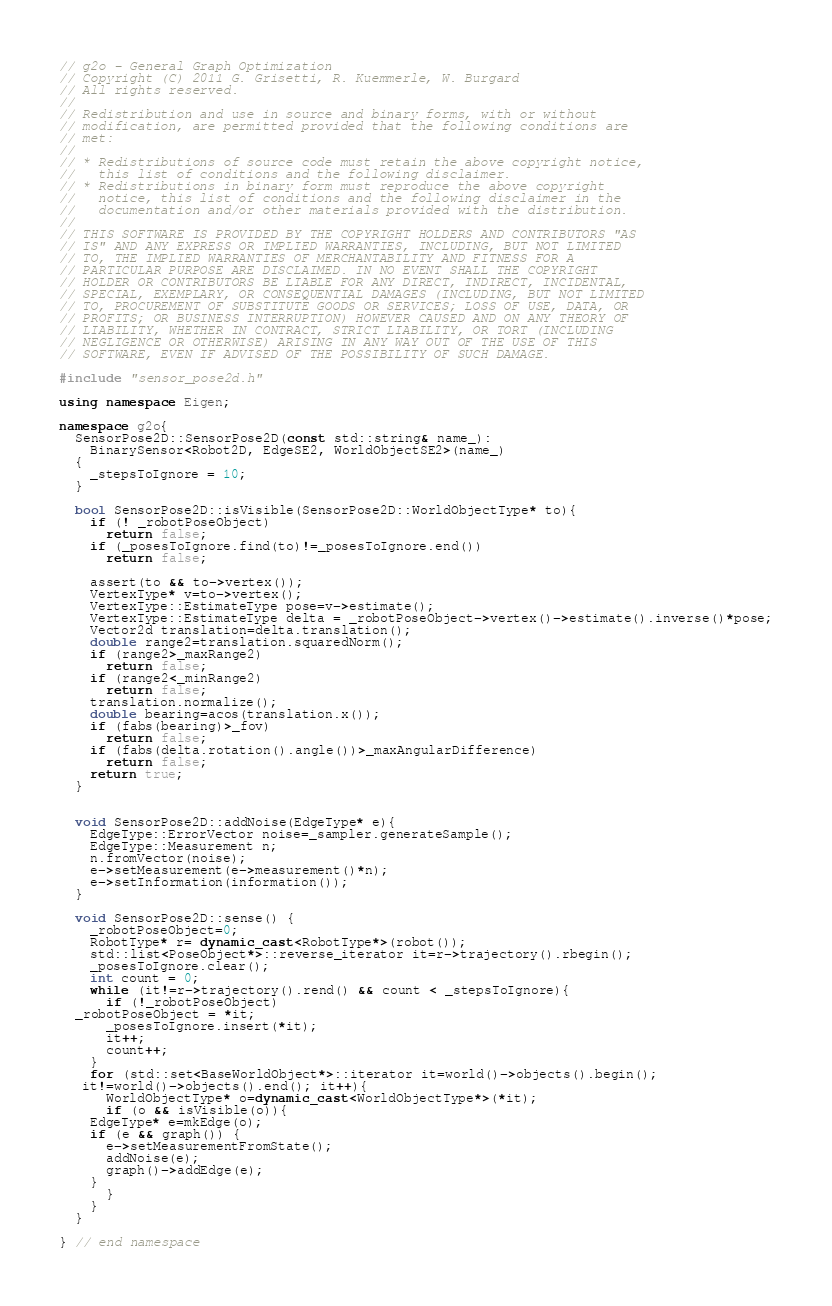Convert code to text. <code><loc_0><loc_0><loc_500><loc_500><_C++_>// g2o - General Graph Optimization
// Copyright (C) 2011 G. Grisetti, R. Kuemmerle, W. Burgard
// All rights reserved.
//
// Redistribution and use in source and binary forms, with or without
// modification, are permitted provided that the following conditions are
// met:
//
// * Redistributions of source code must retain the above copyright notice,
//   this list of conditions and the following disclaimer.
// * Redistributions in binary form must reproduce the above copyright
//   notice, this list of conditions and the following disclaimer in the
//   documentation and/or other materials provided with the distribution.
//
// THIS SOFTWARE IS PROVIDED BY THE COPYRIGHT HOLDERS AND CONTRIBUTORS "AS
// IS" AND ANY EXPRESS OR IMPLIED WARRANTIES, INCLUDING, BUT NOT LIMITED
// TO, THE IMPLIED WARRANTIES OF MERCHANTABILITY AND FITNESS FOR A
// PARTICULAR PURPOSE ARE DISCLAIMED. IN NO EVENT SHALL THE COPYRIGHT
// HOLDER OR CONTRIBUTORS BE LIABLE FOR ANY DIRECT, INDIRECT, INCIDENTAL,
// SPECIAL, EXEMPLARY, OR CONSEQUENTIAL DAMAGES (INCLUDING, BUT NOT LIMITED
// TO, PROCUREMENT OF SUBSTITUTE GOODS OR SERVICES; LOSS OF USE, DATA, OR
// PROFITS; OR BUSINESS INTERRUPTION) HOWEVER CAUSED AND ON ANY THEORY OF
// LIABILITY, WHETHER IN CONTRACT, STRICT LIABILITY, OR TORT (INCLUDING
// NEGLIGENCE OR OTHERWISE) ARISING IN ANY WAY OUT OF THE USE OF THIS
// SOFTWARE, EVEN IF ADVISED OF THE POSSIBILITY OF SUCH DAMAGE.

#include "sensor_pose2d.h"

using namespace Eigen;

namespace g2o{
  SensorPose2D::SensorPose2D(const std::string& name_):
    BinarySensor<Robot2D, EdgeSE2, WorldObjectSE2>(name_)
  {
    _stepsToIgnore = 10;
  }

  bool SensorPose2D::isVisible(SensorPose2D::WorldObjectType* to){
    if (! _robotPoseObject)
      return false;
    if (_posesToIgnore.find(to)!=_posesToIgnore.end())
      return false;
    
    assert(to && to->vertex());
    VertexType* v=to->vertex();
    VertexType::EstimateType pose=v->estimate();
    VertexType::EstimateType delta = _robotPoseObject->vertex()->estimate().inverse()*pose;
    Vector2d translation=delta.translation();
    double range2=translation.squaredNorm();
    if (range2>_maxRange2)
      return false;
    if (range2<_minRange2)
      return false;
    translation.normalize();
    double bearing=acos(translation.x());
    if (fabs(bearing)>_fov)
      return false;
    if (fabs(delta.rotation().angle())>_maxAngularDifference)
      return false;
    return true;
  }
  

  void SensorPose2D::addNoise(EdgeType* e){
    EdgeType::ErrorVector noise=_sampler.generateSample();
    EdgeType::Measurement n;
    n.fromVector(noise);
    e->setMeasurement(e->measurement()*n);
    e->setInformation(information());
  }
 
  void SensorPose2D::sense() {
    _robotPoseObject=0;
    RobotType* r= dynamic_cast<RobotType*>(robot());
    std::list<PoseObject*>::reverse_iterator it=r->trajectory().rbegin();
    _posesToIgnore.clear();
    int count = 0;
    while (it!=r->trajectory().rend() && count < _stepsToIgnore){
      if (!_robotPoseObject)
  _robotPoseObject = *it;
      _posesToIgnore.insert(*it);
      it++;
      count++;
    }
    for (std::set<BaseWorldObject*>::iterator it=world()->objects().begin();
   it!=world()->objects().end(); it++){
      WorldObjectType* o=dynamic_cast<WorldObjectType*>(*it);
      if (o && isVisible(o)){
	EdgeType* e=mkEdge(o);  
	if (e && graph()) {
	  e->setMeasurementFromState();
	  addNoise(e);
	  graph()->addEdge(e);
	}
      }
    }
  }

} // end namespace
</code> 